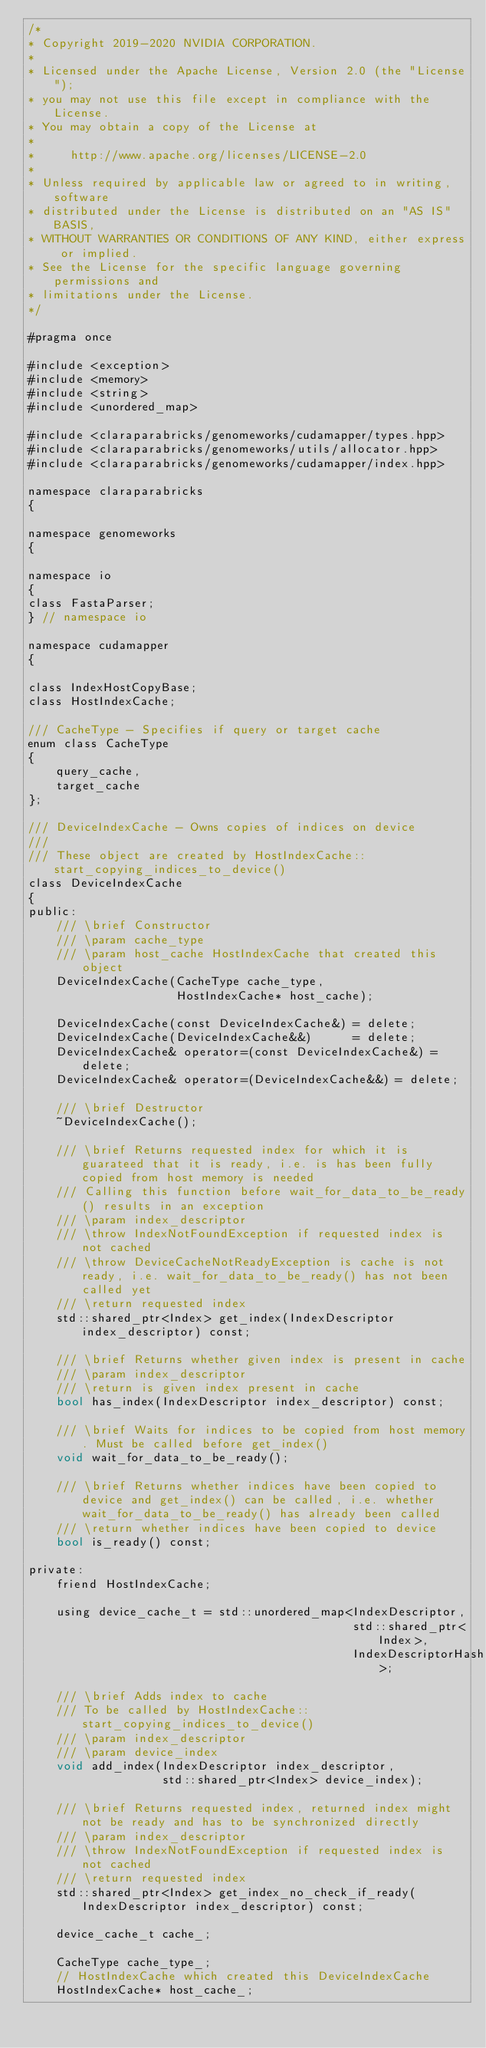<code> <loc_0><loc_0><loc_500><loc_500><_Cuda_>/*
* Copyright 2019-2020 NVIDIA CORPORATION.
*
* Licensed under the Apache License, Version 2.0 (the "License");
* you may not use this file except in compliance with the License.
* You may obtain a copy of the License at
*
*     http://www.apache.org/licenses/LICENSE-2.0
*
* Unless required by applicable law or agreed to in writing, software
* distributed under the License is distributed on an "AS IS" BASIS,
* WITHOUT WARRANTIES OR CONDITIONS OF ANY KIND, either express or implied.
* See the License for the specific language governing permissions and
* limitations under the License.
*/

#pragma once

#include <exception>
#include <memory>
#include <string>
#include <unordered_map>

#include <claraparabricks/genomeworks/cudamapper/types.hpp>
#include <claraparabricks/genomeworks/utils/allocator.hpp>
#include <claraparabricks/genomeworks/cudamapper/index.hpp>

namespace claraparabricks
{

namespace genomeworks
{

namespace io
{
class FastaParser;
} // namespace io

namespace cudamapper
{

class IndexHostCopyBase;
class HostIndexCache;

/// CacheType - Specifies if query or target cache
enum class CacheType
{
    query_cache,
    target_cache
};

/// DeviceIndexCache - Owns copies of indices on device
///
/// These object are created by HostIndexCache::start_copying_indices_to_device()
class DeviceIndexCache
{
public:
    /// \brief Constructor
    /// \param cache_type
    /// \param host_cache HostIndexCache that created this object
    DeviceIndexCache(CacheType cache_type,
                     HostIndexCache* host_cache);

    DeviceIndexCache(const DeviceIndexCache&) = delete;
    DeviceIndexCache(DeviceIndexCache&&)      = delete;
    DeviceIndexCache& operator=(const DeviceIndexCache&) = delete;
    DeviceIndexCache& operator=(DeviceIndexCache&&) = delete;

    /// \brief Destructor
    ~DeviceIndexCache();

    /// \brief Returns requested index for which it is guarateed that it is ready, i.e. is has been fully copied from host memory is needed
    /// Calling this function before wait_for_data_to_be_ready() results in an exception
    /// \param index_descriptor
    /// \throw IndexNotFoundException if requested index is not cached
    /// \throw DeviceCacheNotReadyException is cache is not ready, i.e. wait_for_data_to_be_ready() has not been called yet
    /// \return requested index
    std::shared_ptr<Index> get_index(IndexDescriptor index_descriptor) const;

    /// \brief Returns whether given index is present in cache
    /// \param index_descriptor
    /// \return is given index present in cache
    bool has_index(IndexDescriptor index_descriptor) const;

    /// \brief Waits for indices to be copied from host memory. Must be called before get_index()
    void wait_for_data_to_be_ready();

    /// \brief Returns whether indices have been copied to device and get_index() can be called, i.e. whether wait_for_data_to_be_ready() has already been called
    /// \return whether indices have been copied to device
    bool is_ready() const;

private:
    friend HostIndexCache;

    using device_cache_t = std::unordered_map<IndexDescriptor,
                                              std::shared_ptr<Index>,
                                              IndexDescriptorHash>;

    /// \brief Adds index to cache
    /// To be called by HostIndexCache::start_copying_indices_to_device()
    /// \param index_descriptor
    /// \param device_index
    void add_index(IndexDescriptor index_descriptor,
                   std::shared_ptr<Index> device_index);

    /// \brief Returns requested index, returned index might not be ready and has to be synchronized directly
    /// \param index_descriptor
    /// \throw IndexNotFoundException if requested index is not cached
    /// \return requested index
    std::shared_ptr<Index> get_index_no_check_if_ready(IndexDescriptor index_descriptor) const;

    device_cache_t cache_;

    CacheType cache_type_;
    // HostIndexCache which created this DeviceIndexCache
    HostIndexCache* host_cache_;
</code> 